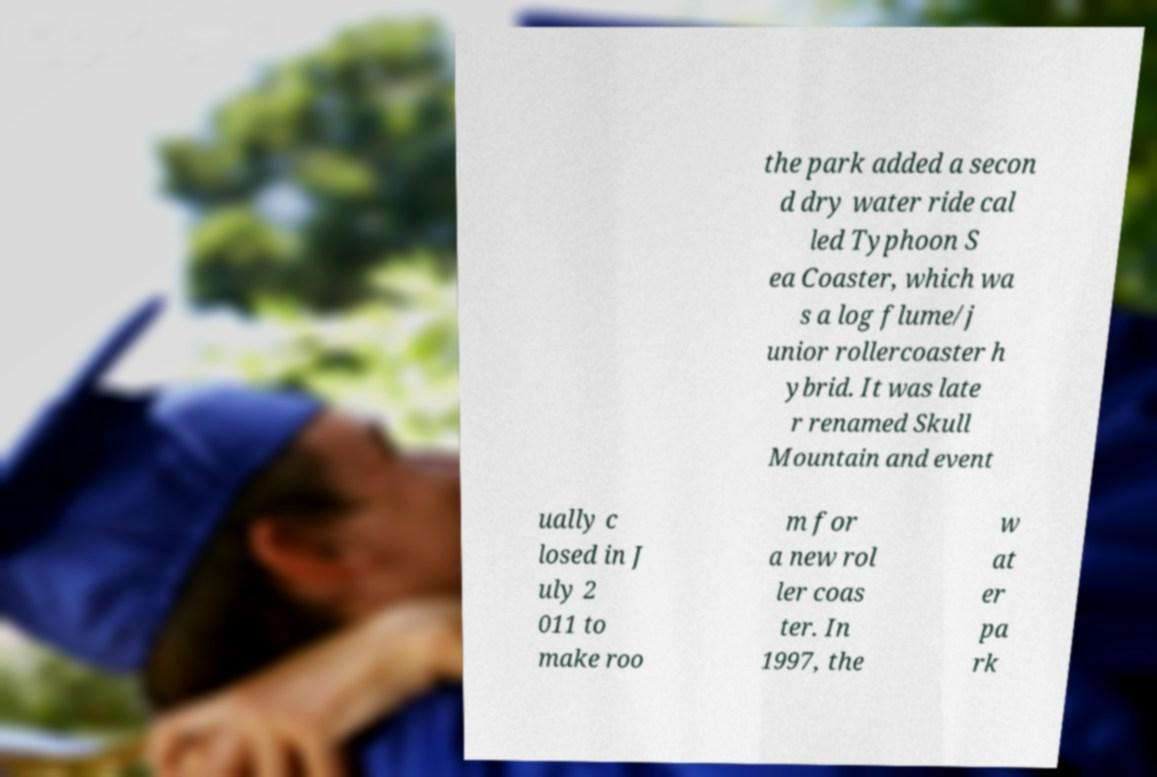Can you accurately transcribe the text from the provided image for me? the park added a secon d dry water ride cal led Typhoon S ea Coaster, which wa s a log flume/j unior rollercoaster h ybrid. It was late r renamed Skull Mountain and event ually c losed in J uly 2 011 to make roo m for a new rol ler coas ter. In 1997, the w at er pa rk 